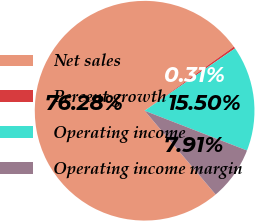Convert chart to OTSL. <chart><loc_0><loc_0><loc_500><loc_500><pie_chart><fcel>Net sales<fcel>Percent growth<fcel>Operating income<fcel>Operating income margin<nl><fcel>76.28%<fcel>0.31%<fcel>15.5%<fcel>7.91%<nl></chart> 